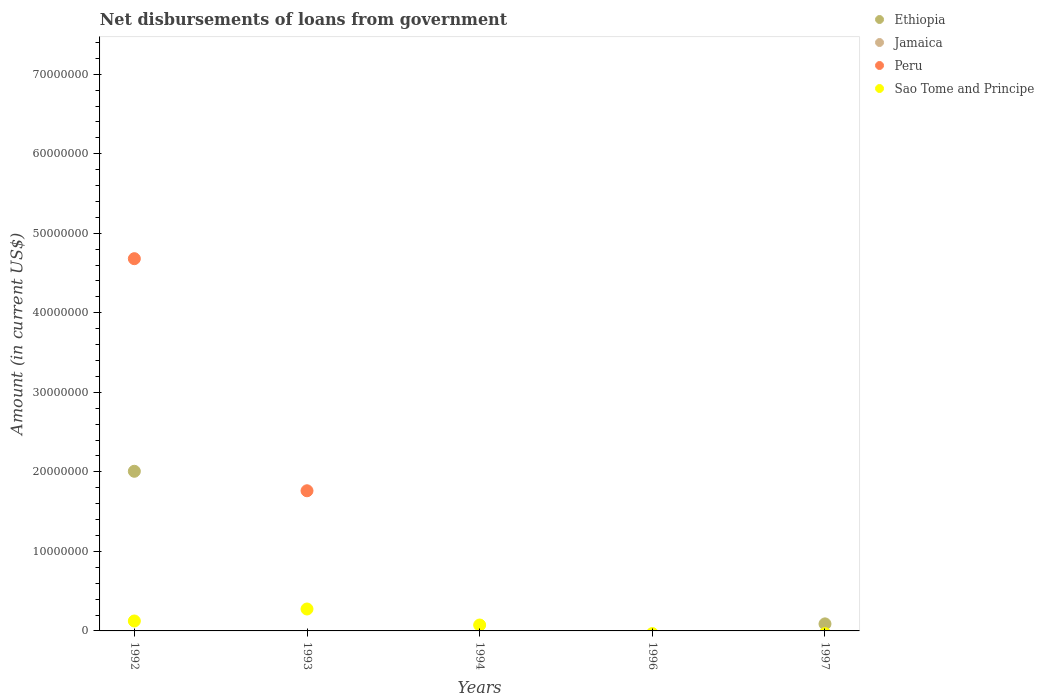How many different coloured dotlines are there?
Provide a short and direct response. 3. Is the number of dotlines equal to the number of legend labels?
Your answer should be compact. No. What is the amount of loan disbursed from government in Sao Tome and Principe in 1992?
Give a very brief answer. 1.25e+06. Across all years, what is the maximum amount of loan disbursed from government in Peru?
Ensure brevity in your answer.  4.68e+07. Across all years, what is the minimum amount of loan disbursed from government in Jamaica?
Your answer should be compact. 0. What is the total amount of loan disbursed from government in Peru in the graph?
Keep it short and to the point. 6.44e+07. What is the difference between the amount of loan disbursed from government in Peru in 1992 and that in 1993?
Offer a terse response. 2.92e+07. What is the difference between the amount of loan disbursed from government in Sao Tome and Principe in 1993 and the amount of loan disbursed from government in Ethiopia in 1992?
Your answer should be very brief. -1.73e+07. What is the average amount of loan disbursed from government in Ethiopia per year?
Ensure brevity in your answer.  4.19e+06. In the year 1992, what is the difference between the amount of loan disbursed from government in Peru and amount of loan disbursed from government in Ethiopia?
Your answer should be very brief. 2.67e+07. In how many years, is the amount of loan disbursed from government in Peru greater than 70000000 US$?
Your answer should be very brief. 0. What is the difference between the highest and the lowest amount of loan disbursed from government in Peru?
Your answer should be very brief. 4.68e+07. Is it the case that in every year, the sum of the amount of loan disbursed from government in Sao Tome and Principe and amount of loan disbursed from government in Peru  is greater than the amount of loan disbursed from government in Jamaica?
Make the answer very short. No. Does the amount of loan disbursed from government in Sao Tome and Principe monotonically increase over the years?
Give a very brief answer. No. Is the amount of loan disbursed from government in Jamaica strictly greater than the amount of loan disbursed from government in Sao Tome and Principe over the years?
Ensure brevity in your answer.  No. Is the amount of loan disbursed from government in Sao Tome and Principe strictly less than the amount of loan disbursed from government in Jamaica over the years?
Your response must be concise. No. Does the graph contain any zero values?
Offer a very short reply. Yes. Does the graph contain grids?
Make the answer very short. No. Where does the legend appear in the graph?
Your answer should be very brief. Top right. How many legend labels are there?
Give a very brief answer. 4. What is the title of the graph?
Provide a succinct answer. Net disbursements of loans from government. What is the label or title of the X-axis?
Make the answer very short. Years. What is the label or title of the Y-axis?
Keep it short and to the point. Amount (in current US$). What is the Amount (in current US$) in Ethiopia in 1992?
Make the answer very short. 2.01e+07. What is the Amount (in current US$) in Peru in 1992?
Offer a very short reply. 4.68e+07. What is the Amount (in current US$) of Sao Tome and Principe in 1992?
Offer a very short reply. 1.25e+06. What is the Amount (in current US$) in Ethiopia in 1993?
Provide a succinct answer. 0. What is the Amount (in current US$) in Peru in 1993?
Offer a terse response. 1.76e+07. What is the Amount (in current US$) of Sao Tome and Principe in 1993?
Make the answer very short. 2.76e+06. What is the Amount (in current US$) of Ethiopia in 1994?
Make the answer very short. 0. What is the Amount (in current US$) in Peru in 1994?
Give a very brief answer. 0. What is the Amount (in current US$) of Sao Tome and Principe in 1994?
Offer a very short reply. 7.42e+05. What is the Amount (in current US$) of Ethiopia in 1996?
Offer a terse response. 0. What is the Amount (in current US$) of Peru in 1996?
Ensure brevity in your answer.  0. What is the Amount (in current US$) of Sao Tome and Principe in 1996?
Make the answer very short. 0. What is the Amount (in current US$) of Ethiopia in 1997?
Ensure brevity in your answer.  8.86e+05. Across all years, what is the maximum Amount (in current US$) in Ethiopia?
Keep it short and to the point. 2.01e+07. Across all years, what is the maximum Amount (in current US$) in Peru?
Provide a short and direct response. 4.68e+07. Across all years, what is the maximum Amount (in current US$) in Sao Tome and Principe?
Your answer should be compact. 2.76e+06. What is the total Amount (in current US$) in Ethiopia in the graph?
Provide a succinct answer. 2.10e+07. What is the total Amount (in current US$) of Peru in the graph?
Offer a terse response. 6.44e+07. What is the total Amount (in current US$) of Sao Tome and Principe in the graph?
Offer a very short reply. 4.75e+06. What is the difference between the Amount (in current US$) of Peru in 1992 and that in 1993?
Provide a succinct answer. 2.92e+07. What is the difference between the Amount (in current US$) in Sao Tome and Principe in 1992 and that in 1993?
Your answer should be compact. -1.51e+06. What is the difference between the Amount (in current US$) in Sao Tome and Principe in 1992 and that in 1994?
Offer a very short reply. 5.07e+05. What is the difference between the Amount (in current US$) of Ethiopia in 1992 and that in 1997?
Your answer should be compact. 1.92e+07. What is the difference between the Amount (in current US$) of Sao Tome and Principe in 1993 and that in 1994?
Provide a succinct answer. 2.01e+06. What is the difference between the Amount (in current US$) in Ethiopia in 1992 and the Amount (in current US$) in Peru in 1993?
Your answer should be very brief. 2.45e+06. What is the difference between the Amount (in current US$) of Ethiopia in 1992 and the Amount (in current US$) of Sao Tome and Principe in 1993?
Ensure brevity in your answer.  1.73e+07. What is the difference between the Amount (in current US$) of Peru in 1992 and the Amount (in current US$) of Sao Tome and Principe in 1993?
Your answer should be very brief. 4.40e+07. What is the difference between the Amount (in current US$) of Ethiopia in 1992 and the Amount (in current US$) of Sao Tome and Principe in 1994?
Provide a succinct answer. 1.93e+07. What is the difference between the Amount (in current US$) of Peru in 1992 and the Amount (in current US$) of Sao Tome and Principe in 1994?
Your answer should be very brief. 4.61e+07. What is the difference between the Amount (in current US$) of Peru in 1993 and the Amount (in current US$) of Sao Tome and Principe in 1994?
Provide a short and direct response. 1.69e+07. What is the average Amount (in current US$) of Ethiopia per year?
Offer a very short reply. 4.19e+06. What is the average Amount (in current US$) in Jamaica per year?
Your answer should be very brief. 0. What is the average Amount (in current US$) of Peru per year?
Your answer should be very brief. 1.29e+07. What is the average Amount (in current US$) of Sao Tome and Principe per year?
Give a very brief answer. 9.49e+05. In the year 1992, what is the difference between the Amount (in current US$) of Ethiopia and Amount (in current US$) of Peru?
Ensure brevity in your answer.  -2.67e+07. In the year 1992, what is the difference between the Amount (in current US$) in Ethiopia and Amount (in current US$) in Sao Tome and Principe?
Keep it short and to the point. 1.88e+07. In the year 1992, what is the difference between the Amount (in current US$) of Peru and Amount (in current US$) of Sao Tome and Principe?
Offer a very short reply. 4.56e+07. In the year 1993, what is the difference between the Amount (in current US$) of Peru and Amount (in current US$) of Sao Tome and Principe?
Your answer should be very brief. 1.49e+07. What is the ratio of the Amount (in current US$) of Peru in 1992 to that in 1993?
Give a very brief answer. 2.66. What is the ratio of the Amount (in current US$) of Sao Tome and Principe in 1992 to that in 1993?
Keep it short and to the point. 0.45. What is the ratio of the Amount (in current US$) in Sao Tome and Principe in 1992 to that in 1994?
Ensure brevity in your answer.  1.68. What is the ratio of the Amount (in current US$) in Ethiopia in 1992 to that in 1997?
Provide a short and direct response. 22.66. What is the ratio of the Amount (in current US$) of Sao Tome and Principe in 1993 to that in 1994?
Provide a short and direct response. 3.71. What is the difference between the highest and the second highest Amount (in current US$) in Sao Tome and Principe?
Keep it short and to the point. 1.51e+06. What is the difference between the highest and the lowest Amount (in current US$) of Ethiopia?
Ensure brevity in your answer.  2.01e+07. What is the difference between the highest and the lowest Amount (in current US$) in Peru?
Your answer should be compact. 4.68e+07. What is the difference between the highest and the lowest Amount (in current US$) in Sao Tome and Principe?
Ensure brevity in your answer.  2.76e+06. 